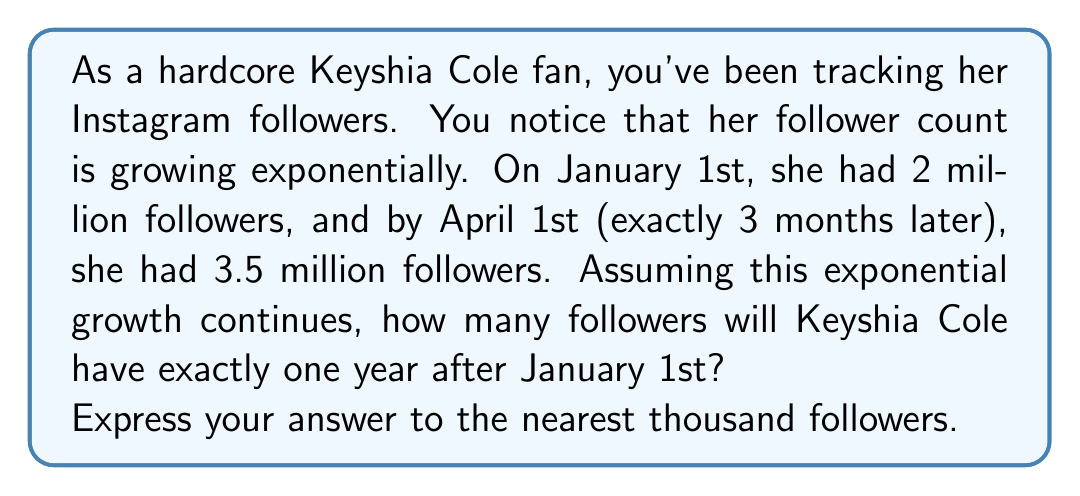Solve this math problem. Let's approach this step-by-step using the exponential growth formula:

$$A = P(1 + r)^t$$

Where:
$A$ = Final amount
$P$ = Initial amount
$r$ = Growth rate (per unit time)
$t$ = Time

1) We know:
   $P = 2,000,000$ (initial followers)
   $A = 3,500,000$ (followers after 3 months)
   $t = 3$ (months)

2) Let's find the monthly growth rate $r$:

   $$3,500,000 = 2,000,000(1 + r)^3$$

3) Divide both sides by 2,000,000:

   $$1.75 = (1 + r)^3$$

4) Take the cube root of both sides:

   $$\sqrt[3]{1.75} = 1 + r$$

5) Solve for $r$:

   $$r = \sqrt[3]{1.75} - 1 \approx 0.2066$$

6) Now that we have $r$, let's find the number of followers after one year (12 months):

   $$A = 2,000,000(1 + 0.2066)^{12}$$

7) Calculate:

   $$A \approx 2,000,000(10.0595) \approx 20,118,984$$

8) Rounding to the nearest thousand:

   $$A \approx 20,119,000$$
Answer: 20,119,000 followers 